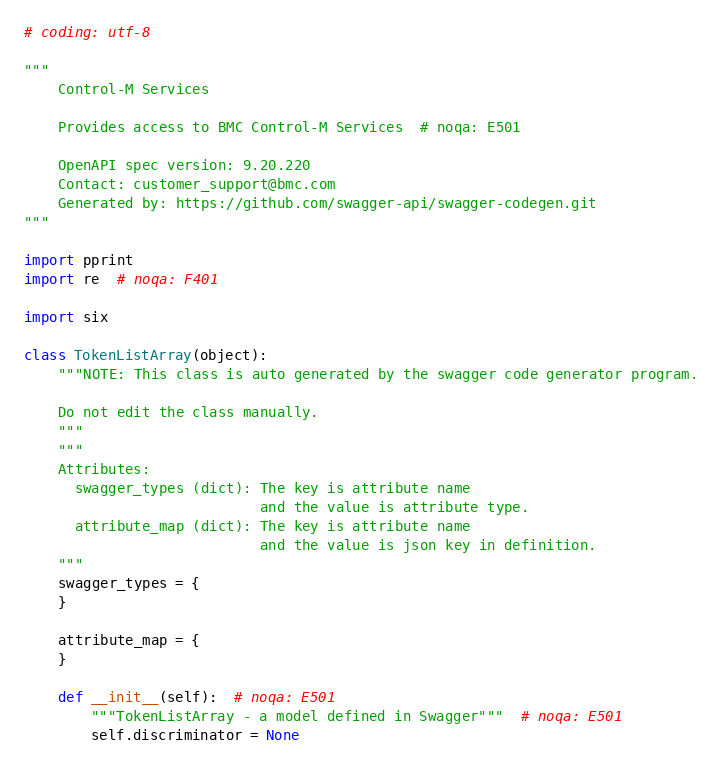Convert code to text. <code><loc_0><loc_0><loc_500><loc_500><_Python_># coding: utf-8

"""
    Control-M Services

    Provides access to BMC Control-M Services  # noqa: E501

    OpenAPI spec version: 9.20.220
    Contact: customer_support@bmc.com
    Generated by: https://github.com/swagger-api/swagger-codegen.git
"""

import pprint
import re  # noqa: F401

import six

class TokenListArray(object):
    """NOTE: This class is auto generated by the swagger code generator program.

    Do not edit the class manually.
    """
    """
    Attributes:
      swagger_types (dict): The key is attribute name
                            and the value is attribute type.
      attribute_map (dict): The key is attribute name
                            and the value is json key in definition.
    """
    swagger_types = {
    }

    attribute_map = {
    }

    def __init__(self):  # noqa: E501
        """TokenListArray - a model defined in Swagger"""  # noqa: E501
        self.discriminator = None
</code> 